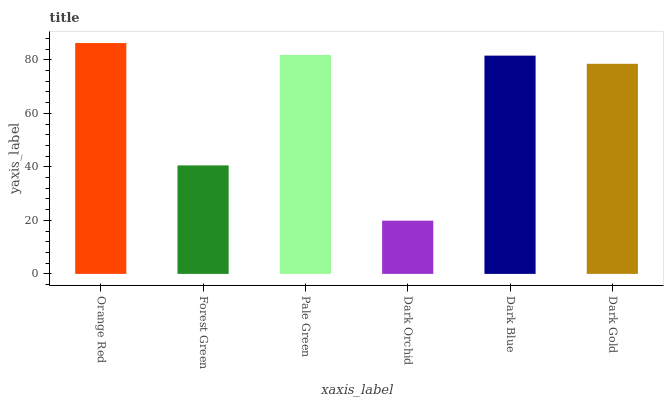Is Dark Orchid the minimum?
Answer yes or no. Yes. Is Orange Red the maximum?
Answer yes or no. Yes. Is Forest Green the minimum?
Answer yes or no. No. Is Forest Green the maximum?
Answer yes or no. No. Is Orange Red greater than Forest Green?
Answer yes or no. Yes. Is Forest Green less than Orange Red?
Answer yes or no. Yes. Is Forest Green greater than Orange Red?
Answer yes or no. No. Is Orange Red less than Forest Green?
Answer yes or no. No. Is Dark Blue the high median?
Answer yes or no. Yes. Is Dark Gold the low median?
Answer yes or no. Yes. Is Dark Orchid the high median?
Answer yes or no. No. Is Forest Green the low median?
Answer yes or no. No. 